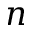<formula> <loc_0><loc_0><loc_500><loc_500>n</formula> 